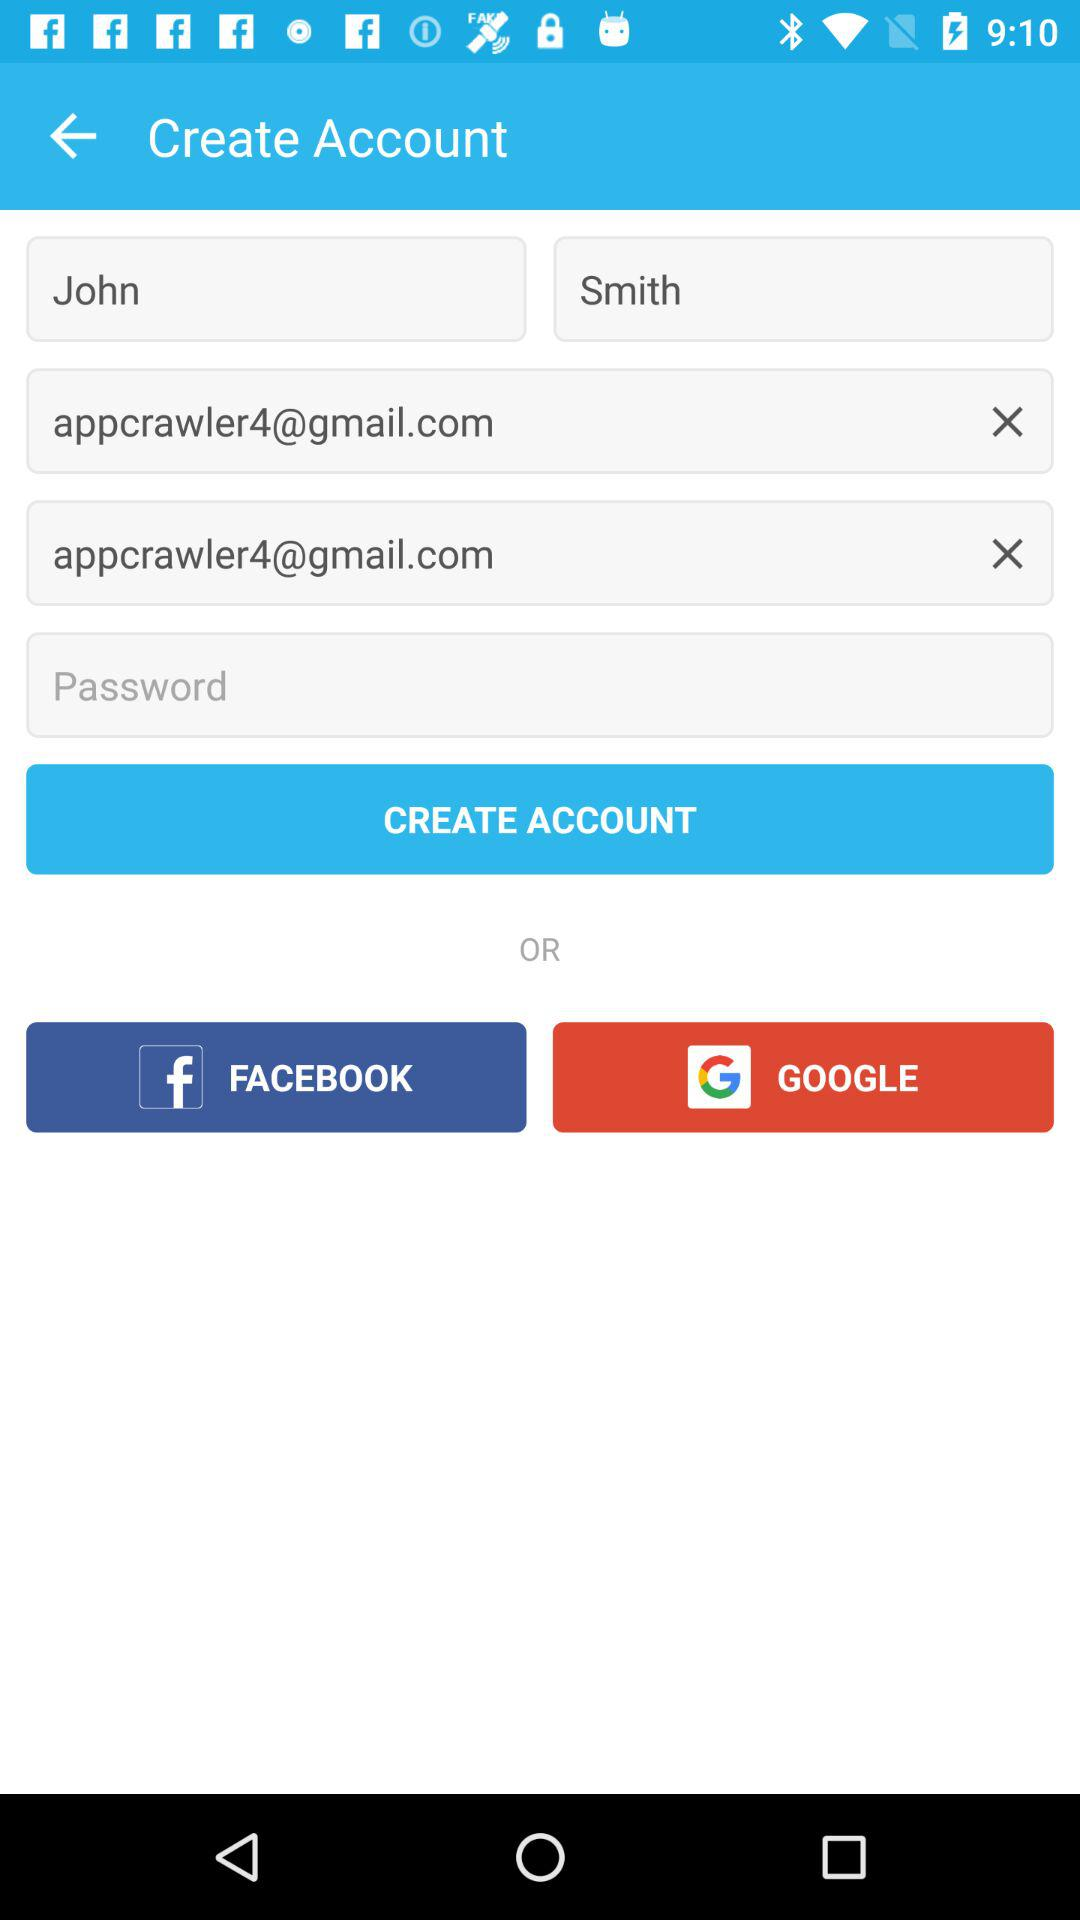What is the last name? The last name is Smith. 